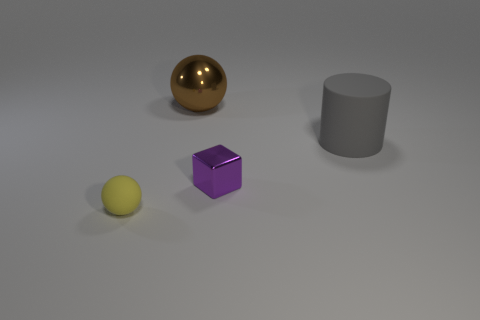Add 4 purple objects. How many objects exist? 8 Subtract all cylinders. How many objects are left? 3 Add 4 metal blocks. How many metal blocks are left? 5 Add 3 small gray balls. How many small gray balls exist? 3 Subtract 0 green cylinders. How many objects are left? 4 Subtract all big cyan matte balls. Subtract all rubber things. How many objects are left? 2 